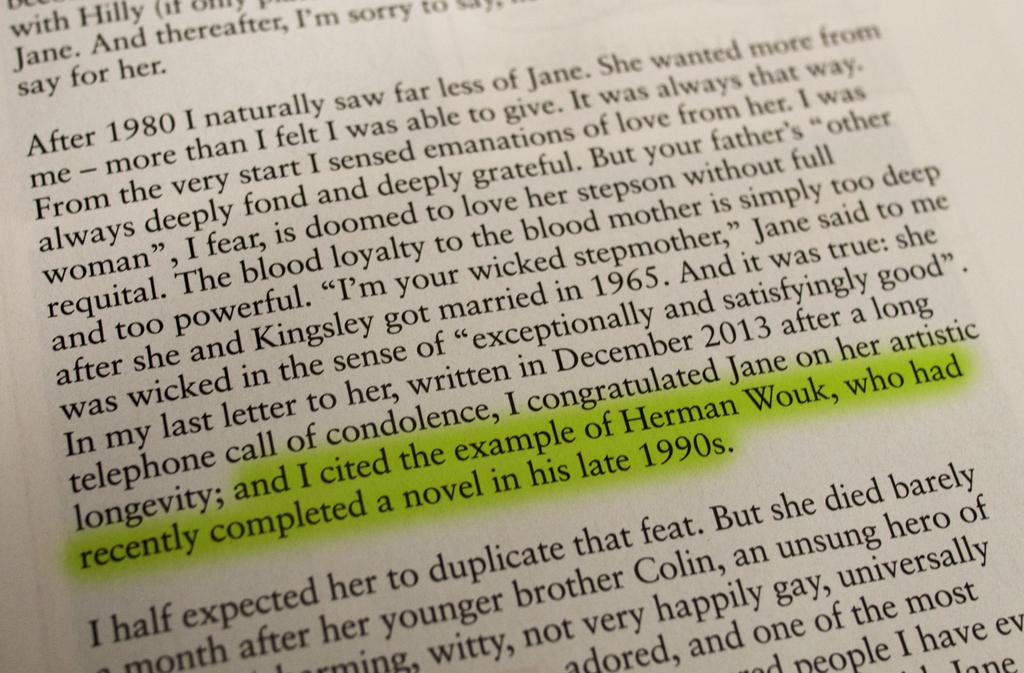What does the highlighted text say?
Provide a succinct answer. And i cited the example of herman wouk, who had recently completed a novel in his late 1990s. After what year did the author see less of jane?
Your answer should be very brief. 1980. 